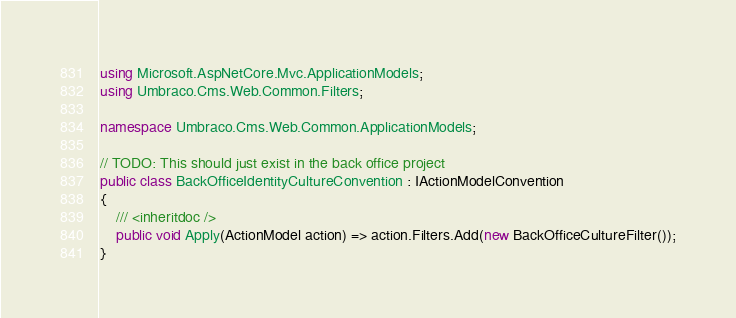Convert code to text. <code><loc_0><loc_0><loc_500><loc_500><_C#_>using Microsoft.AspNetCore.Mvc.ApplicationModels;
using Umbraco.Cms.Web.Common.Filters;

namespace Umbraco.Cms.Web.Common.ApplicationModels;

// TODO: This should just exist in the back office project
public class BackOfficeIdentityCultureConvention : IActionModelConvention
{
    /// <inheritdoc />
    public void Apply(ActionModel action) => action.Filters.Add(new BackOfficeCultureFilter());
}
</code> 